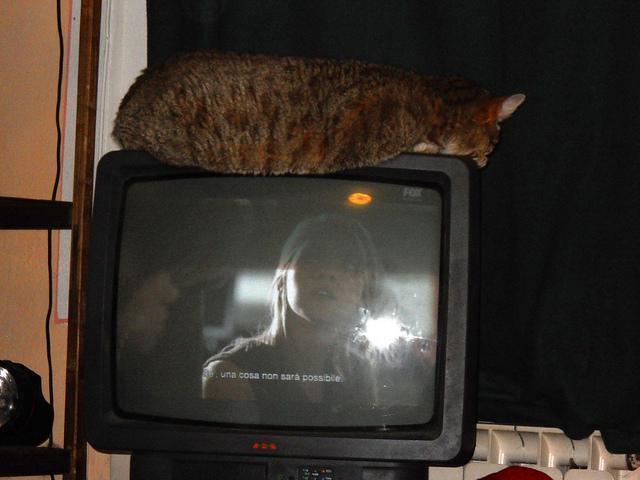Why is the cat sitting here?
Answer the question by selecting the correct answer among the 4 following choices and explain your choice with a short sentence. The answer should be formatted with the following format: `Answer: choice
Rationale: rationale.`
Options: To hunt, to eat, warmth, to hide. Answer: warmth.
Rationale: The cat is sitting on a television. it gives off heat. 